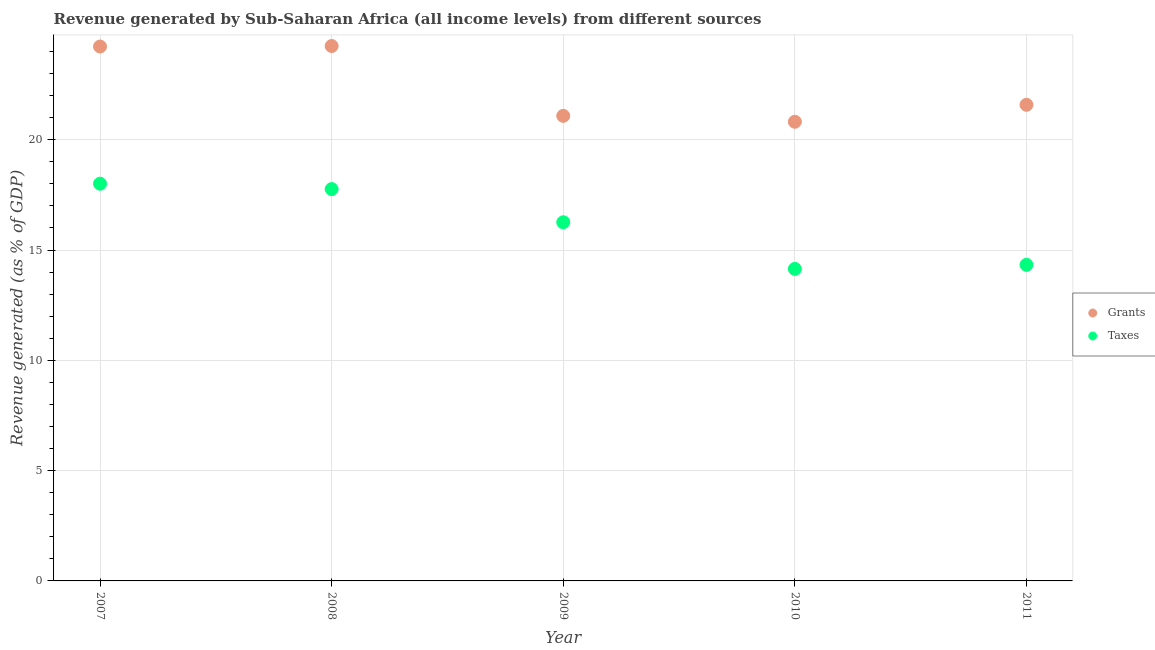How many different coloured dotlines are there?
Your answer should be compact. 2. What is the revenue generated by taxes in 2009?
Offer a terse response. 16.26. Across all years, what is the maximum revenue generated by grants?
Give a very brief answer. 24.25. Across all years, what is the minimum revenue generated by taxes?
Make the answer very short. 14.15. In which year was the revenue generated by taxes maximum?
Your response must be concise. 2007. In which year was the revenue generated by taxes minimum?
Give a very brief answer. 2010. What is the total revenue generated by taxes in the graph?
Your response must be concise. 80.51. What is the difference between the revenue generated by taxes in 2007 and that in 2009?
Offer a very short reply. 1.75. What is the difference between the revenue generated by grants in 2007 and the revenue generated by taxes in 2009?
Your answer should be very brief. 7.97. What is the average revenue generated by taxes per year?
Provide a succinct answer. 16.1. In the year 2008, what is the difference between the revenue generated by taxes and revenue generated by grants?
Offer a very short reply. -6.49. What is the ratio of the revenue generated by taxes in 2007 to that in 2011?
Give a very brief answer. 1.26. Is the revenue generated by grants in 2008 less than that in 2010?
Give a very brief answer. No. What is the difference between the highest and the second highest revenue generated by taxes?
Keep it short and to the point. 0.24. What is the difference between the highest and the lowest revenue generated by taxes?
Provide a short and direct response. 3.86. In how many years, is the revenue generated by grants greater than the average revenue generated by grants taken over all years?
Offer a very short reply. 2. Does the revenue generated by grants monotonically increase over the years?
Your answer should be very brief. No. Is the revenue generated by grants strictly less than the revenue generated by taxes over the years?
Give a very brief answer. No. How many years are there in the graph?
Ensure brevity in your answer.  5. Are the values on the major ticks of Y-axis written in scientific E-notation?
Give a very brief answer. No. Does the graph contain any zero values?
Your response must be concise. No. How many legend labels are there?
Offer a very short reply. 2. How are the legend labels stacked?
Offer a terse response. Vertical. What is the title of the graph?
Your response must be concise. Revenue generated by Sub-Saharan Africa (all income levels) from different sources. Does "Money lenders" appear as one of the legend labels in the graph?
Your answer should be compact. No. What is the label or title of the X-axis?
Ensure brevity in your answer.  Year. What is the label or title of the Y-axis?
Your answer should be compact. Revenue generated (as % of GDP). What is the Revenue generated (as % of GDP) of Grants in 2007?
Provide a short and direct response. 24.23. What is the Revenue generated (as % of GDP) in Taxes in 2007?
Provide a short and direct response. 18.01. What is the Revenue generated (as % of GDP) in Grants in 2008?
Provide a short and direct response. 24.25. What is the Revenue generated (as % of GDP) in Taxes in 2008?
Provide a short and direct response. 17.76. What is the Revenue generated (as % of GDP) in Grants in 2009?
Your response must be concise. 21.08. What is the Revenue generated (as % of GDP) of Taxes in 2009?
Offer a terse response. 16.26. What is the Revenue generated (as % of GDP) of Grants in 2010?
Ensure brevity in your answer.  20.82. What is the Revenue generated (as % of GDP) of Taxes in 2010?
Your response must be concise. 14.15. What is the Revenue generated (as % of GDP) in Grants in 2011?
Offer a very short reply. 21.58. What is the Revenue generated (as % of GDP) of Taxes in 2011?
Offer a terse response. 14.33. Across all years, what is the maximum Revenue generated (as % of GDP) of Grants?
Your answer should be compact. 24.25. Across all years, what is the maximum Revenue generated (as % of GDP) in Taxes?
Provide a short and direct response. 18.01. Across all years, what is the minimum Revenue generated (as % of GDP) of Grants?
Your response must be concise. 20.82. Across all years, what is the minimum Revenue generated (as % of GDP) of Taxes?
Your answer should be compact. 14.15. What is the total Revenue generated (as % of GDP) in Grants in the graph?
Give a very brief answer. 111.96. What is the total Revenue generated (as % of GDP) of Taxes in the graph?
Make the answer very short. 80.51. What is the difference between the Revenue generated (as % of GDP) in Grants in 2007 and that in 2008?
Offer a very short reply. -0.02. What is the difference between the Revenue generated (as % of GDP) of Taxes in 2007 and that in 2008?
Ensure brevity in your answer.  0.24. What is the difference between the Revenue generated (as % of GDP) of Grants in 2007 and that in 2009?
Keep it short and to the point. 3.14. What is the difference between the Revenue generated (as % of GDP) of Taxes in 2007 and that in 2009?
Give a very brief answer. 1.75. What is the difference between the Revenue generated (as % of GDP) of Grants in 2007 and that in 2010?
Your answer should be very brief. 3.41. What is the difference between the Revenue generated (as % of GDP) in Taxes in 2007 and that in 2010?
Provide a short and direct response. 3.86. What is the difference between the Revenue generated (as % of GDP) in Grants in 2007 and that in 2011?
Keep it short and to the point. 2.64. What is the difference between the Revenue generated (as % of GDP) of Taxes in 2007 and that in 2011?
Your answer should be very brief. 3.68. What is the difference between the Revenue generated (as % of GDP) of Grants in 2008 and that in 2009?
Your answer should be very brief. 3.17. What is the difference between the Revenue generated (as % of GDP) of Taxes in 2008 and that in 2009?
Make the answer very short. 1.5. What is the difference between the Revenue generated (as % of GDP) in Grants in 2008 and that in 2010?
Give a very brief answer. 3.43. What is the difference between the Revenue generated (as % of GDP) of Taxes in 2008 and that in 2010?
Your answer should be very brief. 3.62. What is the difference between the Revenue generated (as % of GDP) in Grants in 2008 and that in 2011?
Your answer should be compact. 2.67. What is the difference between the Revenue generated (as % of GDP) of Taxes in 2008 and that in 2011?
Keep it short and to the point. 3.43. What is the difference between the Revenue generated (as % of GDP) of Grants in 2009 and that in 2010?
Provide a short and direct response. 0.27. What is the difference between the Revenue generated (as % of GDP) in Taxes in 2009 and that in 2010?
Your response must be concise. 2.11. What is the difference between the Revenue generated (as % of GDP) in Grants in 2009 and that in 2011?
Your response must be concise. -0.5. What is the difference between the Revenue generated (as % of GDP) of Taxes in 2009 and that in 2011?
Make the answer very short. 1.93. What is the difference between the Revenue generated (as % of GDP) in Grants in 2010 and that in 2011?
Offer a very short reply. -0.77. What is the difference between the Revenue generated (as % of GDP) in Taxes in 2010 and that in 2011?
Provide a succinct answer. -0.18. What is the difference between the Revenue generated (as % of GDP) in Grants in 2007 and the Revenue generated (as % of GDP) in Taxes in 2008?
Your answer should be compact. 6.46. What is the difference between the Revenue generated (as % of GDP) of Grants in 2007 and the Revenue generated (as % of GDP) of Taxes in 2009?
Keep it short and to the point. 7.97. What is the difference between the Revenue generated (as % of GDP) of Grants in 2007 and the Revenue generated (as % of GDP) of Taxes in 2010?
Your response must be concise. 10.08. What is the difference between the Revenue generated (as % of GDP) of Grants in 2007 and the Revenue generated (as % of GDP) of Taxes in 2011?
Provide a succinct answer. 9.9. What is the difference between the Revenue generated (as % of GDP) in Grants in 2008 and the Revenue generated (as % of GDP) in Taxes in 2009?
Your response must be concise. 7.99. What is the difference between the Revenue generated (as % of GDP) of Grants in 2008 and the Revenue generated (as % of GDP) of Taxes in 2010?
Ensure brevity in your answer.  10.1. What is the difference between the Revenue generated (as % of GDP) in Grants in 2008 and the Revenue generated (as % of GDP) in Taxes in 2011?
Make the answer very short. 9.92. What is the difference between the Revenue generated (as % of GDP) of Grants in 2009 and the Revenue generated (as % of GDP) of Taxes in 2010?
Provide a short and direct response. 6.94. What is the difference between the Revenue generated (as % of GDP) in Grants in 2009 and the Revenue generated (as % of GDP) in Taxes in 2011?
Your answer should be very brief. 6.75. What is the difference between the Revenue generated (as % of GDP) of Grants in 2010 and the Revenue generated (as % of GDP) of Taxes in 2011?
Your answer should be very brief. 6.49. What is the average Revenue generated (as % of GDP) in Grants per year?
Your answer should be compact. 22.39. What is the average Revenue generated (as % of GDP) of Taxes per year?
Your response must be concise. 16.1. In the year 2007, what is the difference between the Revenue generated (as % of GDP) in Grants and Revenue generated (as % of GDP) in Taxes?
Keep it short and to the point. 6.22. In the year 2008, what is the difference between the Revenue generated (as % of GDP) of Grants and Revenue generated (as % of GDP) of Taxes?
Keep it short and to the point. 6.49. In the year 2009, what is the difference between the Revenue generated (as % of GDP) of Grants and Revenue generated (as % of GDP) of Taxes?
Give a very brief answer. 4.82. In the year 2010, what is the difference between the Revenue generated (as % of GDP) in Grants and Revenue generated (as % of GDP) in Taxes?
Your response must be concise. 6.67. In the year 2011, what is the difference between the Revenue generated (as % of GDP) in Grants and Revenue generated (as % of GDP) in Taxes?
Offer a terse response. 7.25. What is the ratio of the Revenue generated (as % of GDP) in Grants in 2007 to that in 2008?
Keep it short and to the point. 1. What is the ratio of the Revenue generated (as % of GDP) in Taxes in 2007 to that in 2008?
Provide a short and direct response. 1.01. What is the ratio of the Revenue generated (as % of GDP) in Grants in 2007 to that in 2009?
Offer a terse response. 1.15. What is the ratio of the Revenue generated (as % of GDP) of Taxes in 2007 to that in 2009?
Offer a terse response. 1.11. What is the ratio of the Revenue generated (as % of GDP) of Grants in 2007 to that in 2010?
Keep it short and to the point. 1.16. What is the ratio of the Revenue generated (as % of GDP) in Taxes in 2007 to that in 2010?
Your answer should be compact. 1.27. What is the ratio of the Revenue generated (as % of GDP) in Grants in 2007 to that in 2011?
Provide a short and direct response. 1.12. What is the ratio of the Revenue generated (as % of GDP) of Taxes in 2007 to that in 2011?
Ensure brevity in your answer.  1.26. What is the ratio of the Revenue generated (as % of GDP) of Grants in 2008 to that in 2009?
Ensure brevity in your answer.  1.15. What is the ratio of the Revenue generated (as % of GDP) of Taxes in 2008 to that in 2009?
Offer a terse response. 1.09. What is the ratio of the Revenue generated (as % of GDP) in Grants in 2008 to that in 2010?
Keep it short and to the point. 1.16. What is the ratio of the Revenue generated (as % of GDP) in Taxes in 2008 to that in 2010?
Keep it short and to the point. 1.26. What is the ratio of the Revenue generated (as % of GDP) of Grants in 2008 to that in 2011?
Make the answer very short. 1.12. What is the ratio of the Revenue generated (as % of GDP) of Taxes in 2008 to that in 2011?
Give a very brief answer. 1.24. What is the ratio of the Revenue generated (as % of GDP) of Grants in 2009 to that in 2010?
Make the answer very short. 1.01. What is the ratio of the Revenue generated (as % of GDP) in Taxes in 2009 to that in 2010?
Keep it short and to the point. 1.15. What is the ratio of the Revenue generated (as % of GDP) of Grants in 2009 to that in 2011?
Your answer should be compact. 0.98. What is the ratio of the Revenue generated (as % of GDP) of Taxes in 2009 to that in 2011?
Your answer should be very brief. 1.13. What is the ratio of the Revenue generated (as % of GDP) in Grants in 2010 to that in 2011?
Your answer should be very brief. 0.96. What is the ratio of the Revenue generated (as % of GDP) in Taxes in 2010 to that in 2011?
Make the answer very short. 0.99. What is the difference between the highest and the second highest Revenue generated (as % of GDP) in Grants?
Give a very brief answer. 0.02. What is the difference between the highest and the second highest Revenue generated (as % of GDP) of Taxes?
Offer a very short reply. 0.24. What is the difference between the highest and the lowest Revenue generated (as % of GDP) of Grants?
Your answer should be very brief. 3.43. What is the difference between the highest and the lowest Revenue generated (as % of GDP) in Taxes?
Make the answer very short. 3.86. 